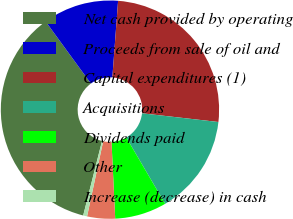Convert chart to OTSL. <chart><loc_0><loc_0><loc_500><loc_500><pie_chart><fcel>Net cash provided by operating<fcel>Proceeds from sale of oil and<fcel>Capital expenditures (1)<fcel>Acquisitions<fcel>Dividends paid<fcel>Other<fcel>Increase (decrease) in cash<nl><fcel>36.03%<fcel>11.22%<fcel>25.62%<fcel>14.76%<fcel>7.67%<fcel>4.13%<fcel>0.58%<nl></chart> 